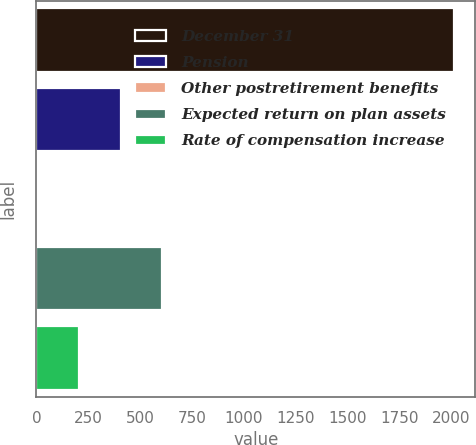Convert chart to OTSL. <chart><loc_0><loc_0><loc_500><loc_500><bar_chart><fcel>December 31<fcel>Pension<fcel>Other postretirement benefits<fcel>Expected return on plan assets<fcel>Rate of compensation increase<nl><fcel>2014<fcel>405.6<fcel>3.5<fcel>606.65<fcel>204.55<nl></chart> 